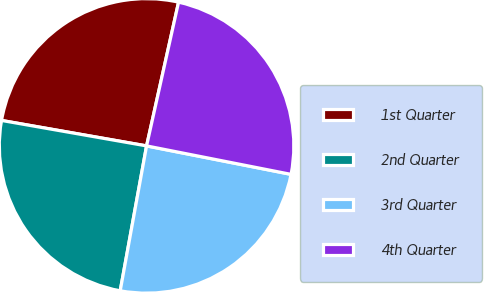Convert chart. <chart><loc_0><loc_0><loc_500><loc_500><pie_chart><fcel>1st Quarter<fcel>2nd Quarter<fcel>3rd Quarter<fcel>4th Quarter<nl><fcel>25.72%<fcel>24.9%<fcel>24.77%<fcel>24.61%<nl></chart> 